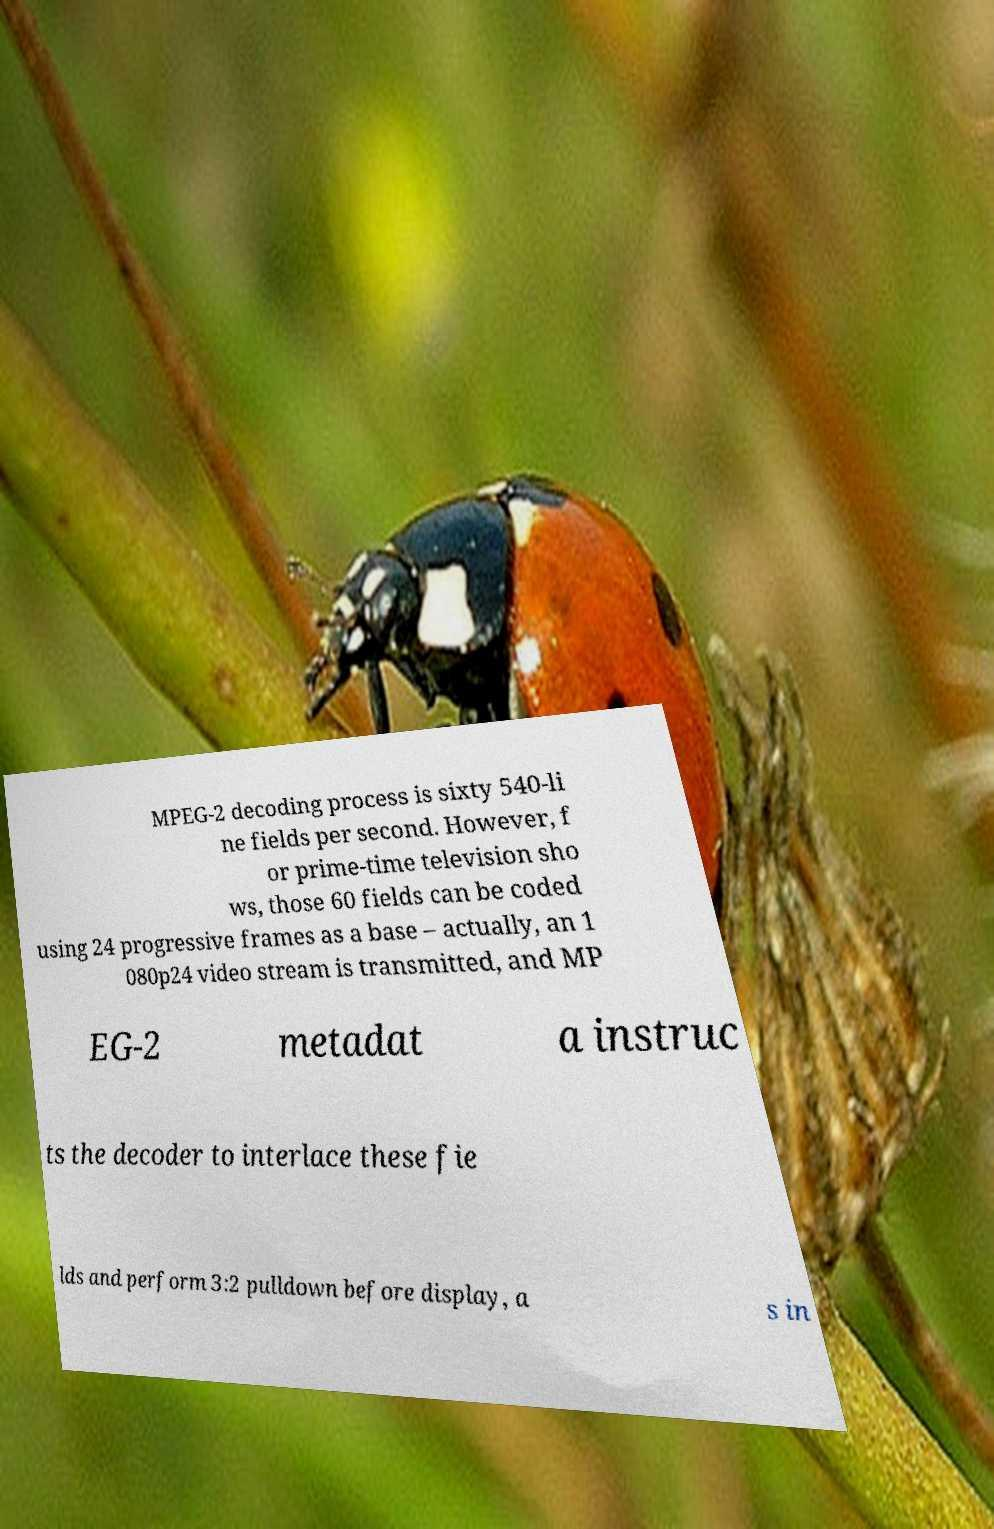Can you accurately transcribe the text from the provided image for me? MPEG-2 decoding process is sixty 540-li ne fields per second. However, f or prime-time television sho ws, those 60 fields can be coded using 24 progressive frames as a base – actually, an 1 080p24 video stream is transmitted, and MP EG-2 metadat a instruc ts the decoder to interlace these fie lds and perform 3:2 pulldown before display, a s in 